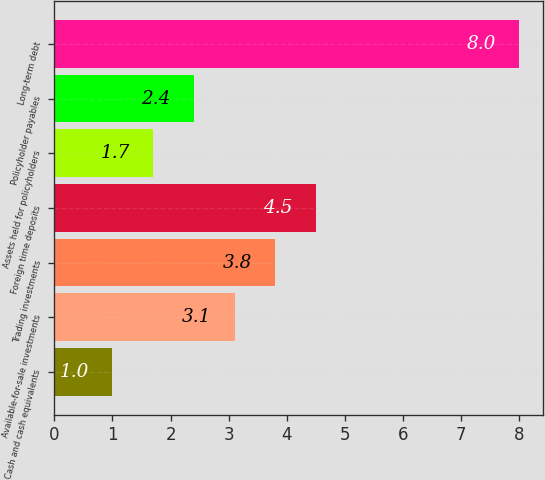Convert chart. <chart><loc_0><loc_0><loc_500><loc_500><bar_chart><fcel>Cash and cash equivalents<fcel>Available-for-sale investments<fcel>Trading investments<fcel>Foreign time deposits<fcel>Assets held for policyholders<fcel>Policyholder payables<fcel>Long-term debt<nl><fcel>1<fcel>3.1<fcel>3.8<fcel>4.5<fcel>1.7<fcel>2.4<fcel>8<nl></chart> 